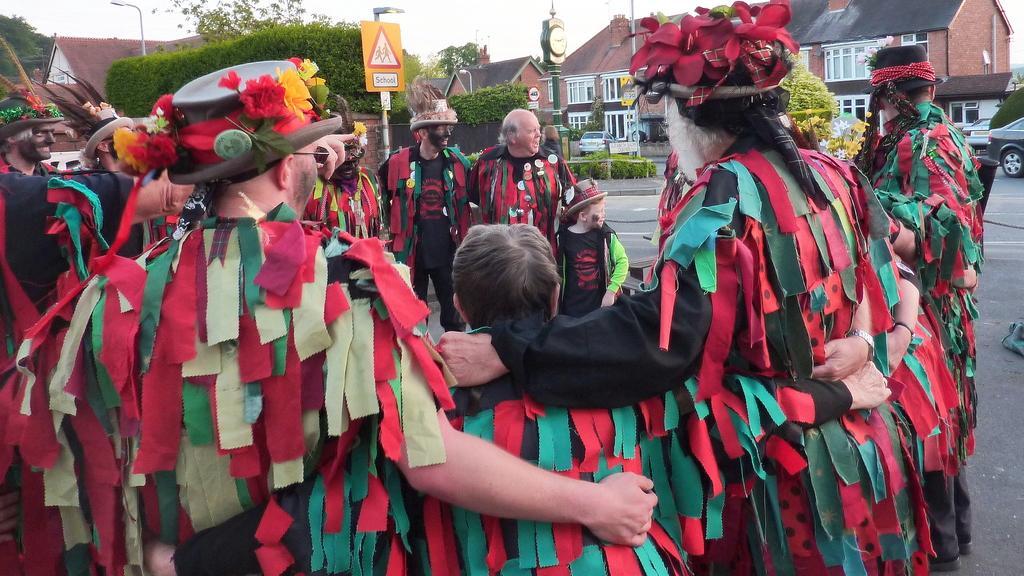Describe this image in one or two sentences. In this image, we can see a group of people are on the road. Background we can see houses, trees, plants, poles, sign board, clock, vehicles, walls, windows, roads and sky. 